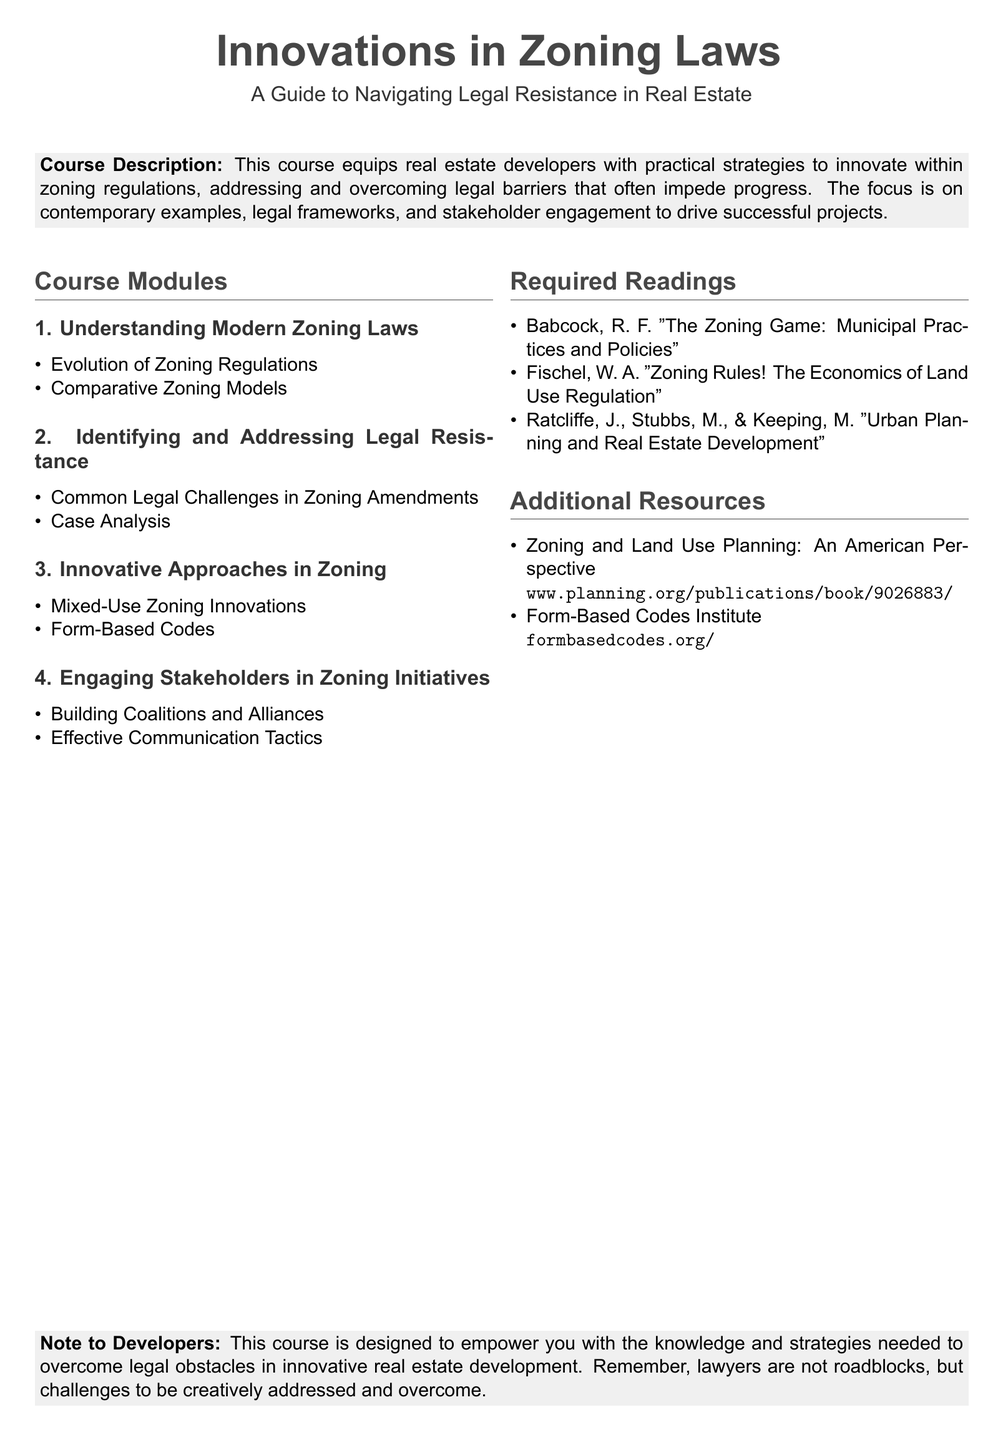What is the title of the course? The title of the course is stated as "Innovations in Zoning Laws".
Answer: Innovations in Zoning Laws How many modules are in the course? The course modules listed are four in total.
Answer: 4 Name one author of the required readings. The required readings list "Babcock, R. F." as one of the authors.
Answer: Babcock, R. F What is a focus area mentioned in the course description? The course description emphasizes "practical strategies" to address legal barriers.
Answer: practical strategies What is one innovative approach covered in the course? The course specifically mentions "Mixed-Use Zoning Innovations" as an innovative approach.
Answer: Mixed-Use Zoning Innovations What is the main purpose of the course? The purpose of the course is to empower developers to navigate legal resistance in real estate.
Answer: empower developers to navigate legal resistance Name one additional resource provided in the document. One of the additional resources listed is "Zoning and Land Use Planning: An American Perspective".
Answer: Zoning and Land Use Planning: An American Perspective Who is the target audience for this course? The target audience mentioned in the document is "real estate developers".
Answer: real estate developers What essential skill is emphasized in engaging stakeholders? "Effective Communication Tactics" is highlighted as an essential skill in engaging stakeholders.
Answer: Effective Communication Tactics 